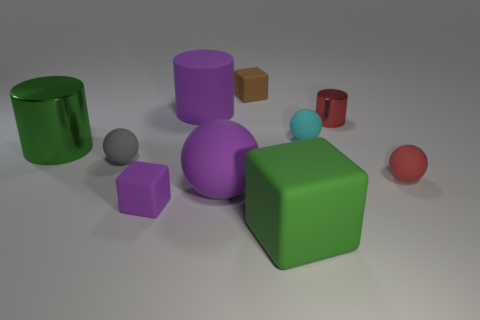Is there a small rubber object of the same color as the tiny cylinder?
Make the answer very short. Yes. What number of tiny blue matte cubes are there?
Your answer should be compact. 0. The big cylinder that is in front of the shiny object that is on the right side of the big green thing behind the red rubber sphere is made of what material?
Your answer should be compact. Metal. Is there a brown thing made of the same material as the gray sphere?
Keep it short and to the point. Yes. Are the small red cylinder and the big block made of the same material?
Offer a terse response. No. What number of cubes are tiny cyan rubber things or metal things?
Your answer should be very brief. 0. There is a cylinder that is the same material as the cyan thing; what color is it?
Offer a very short reply. Purple. Is the number of large green blocks less than the number of tiny brown metallic balls?
Give a very brief answer. No. Is the shape of the green object on the right side of the tiny brown block the same as the tiny purple matte object right of the gray ball?
Ensure brevity in your answer.  Yes. How many objects are either shiny things or purple balls?
Your response must be concise. 3. 